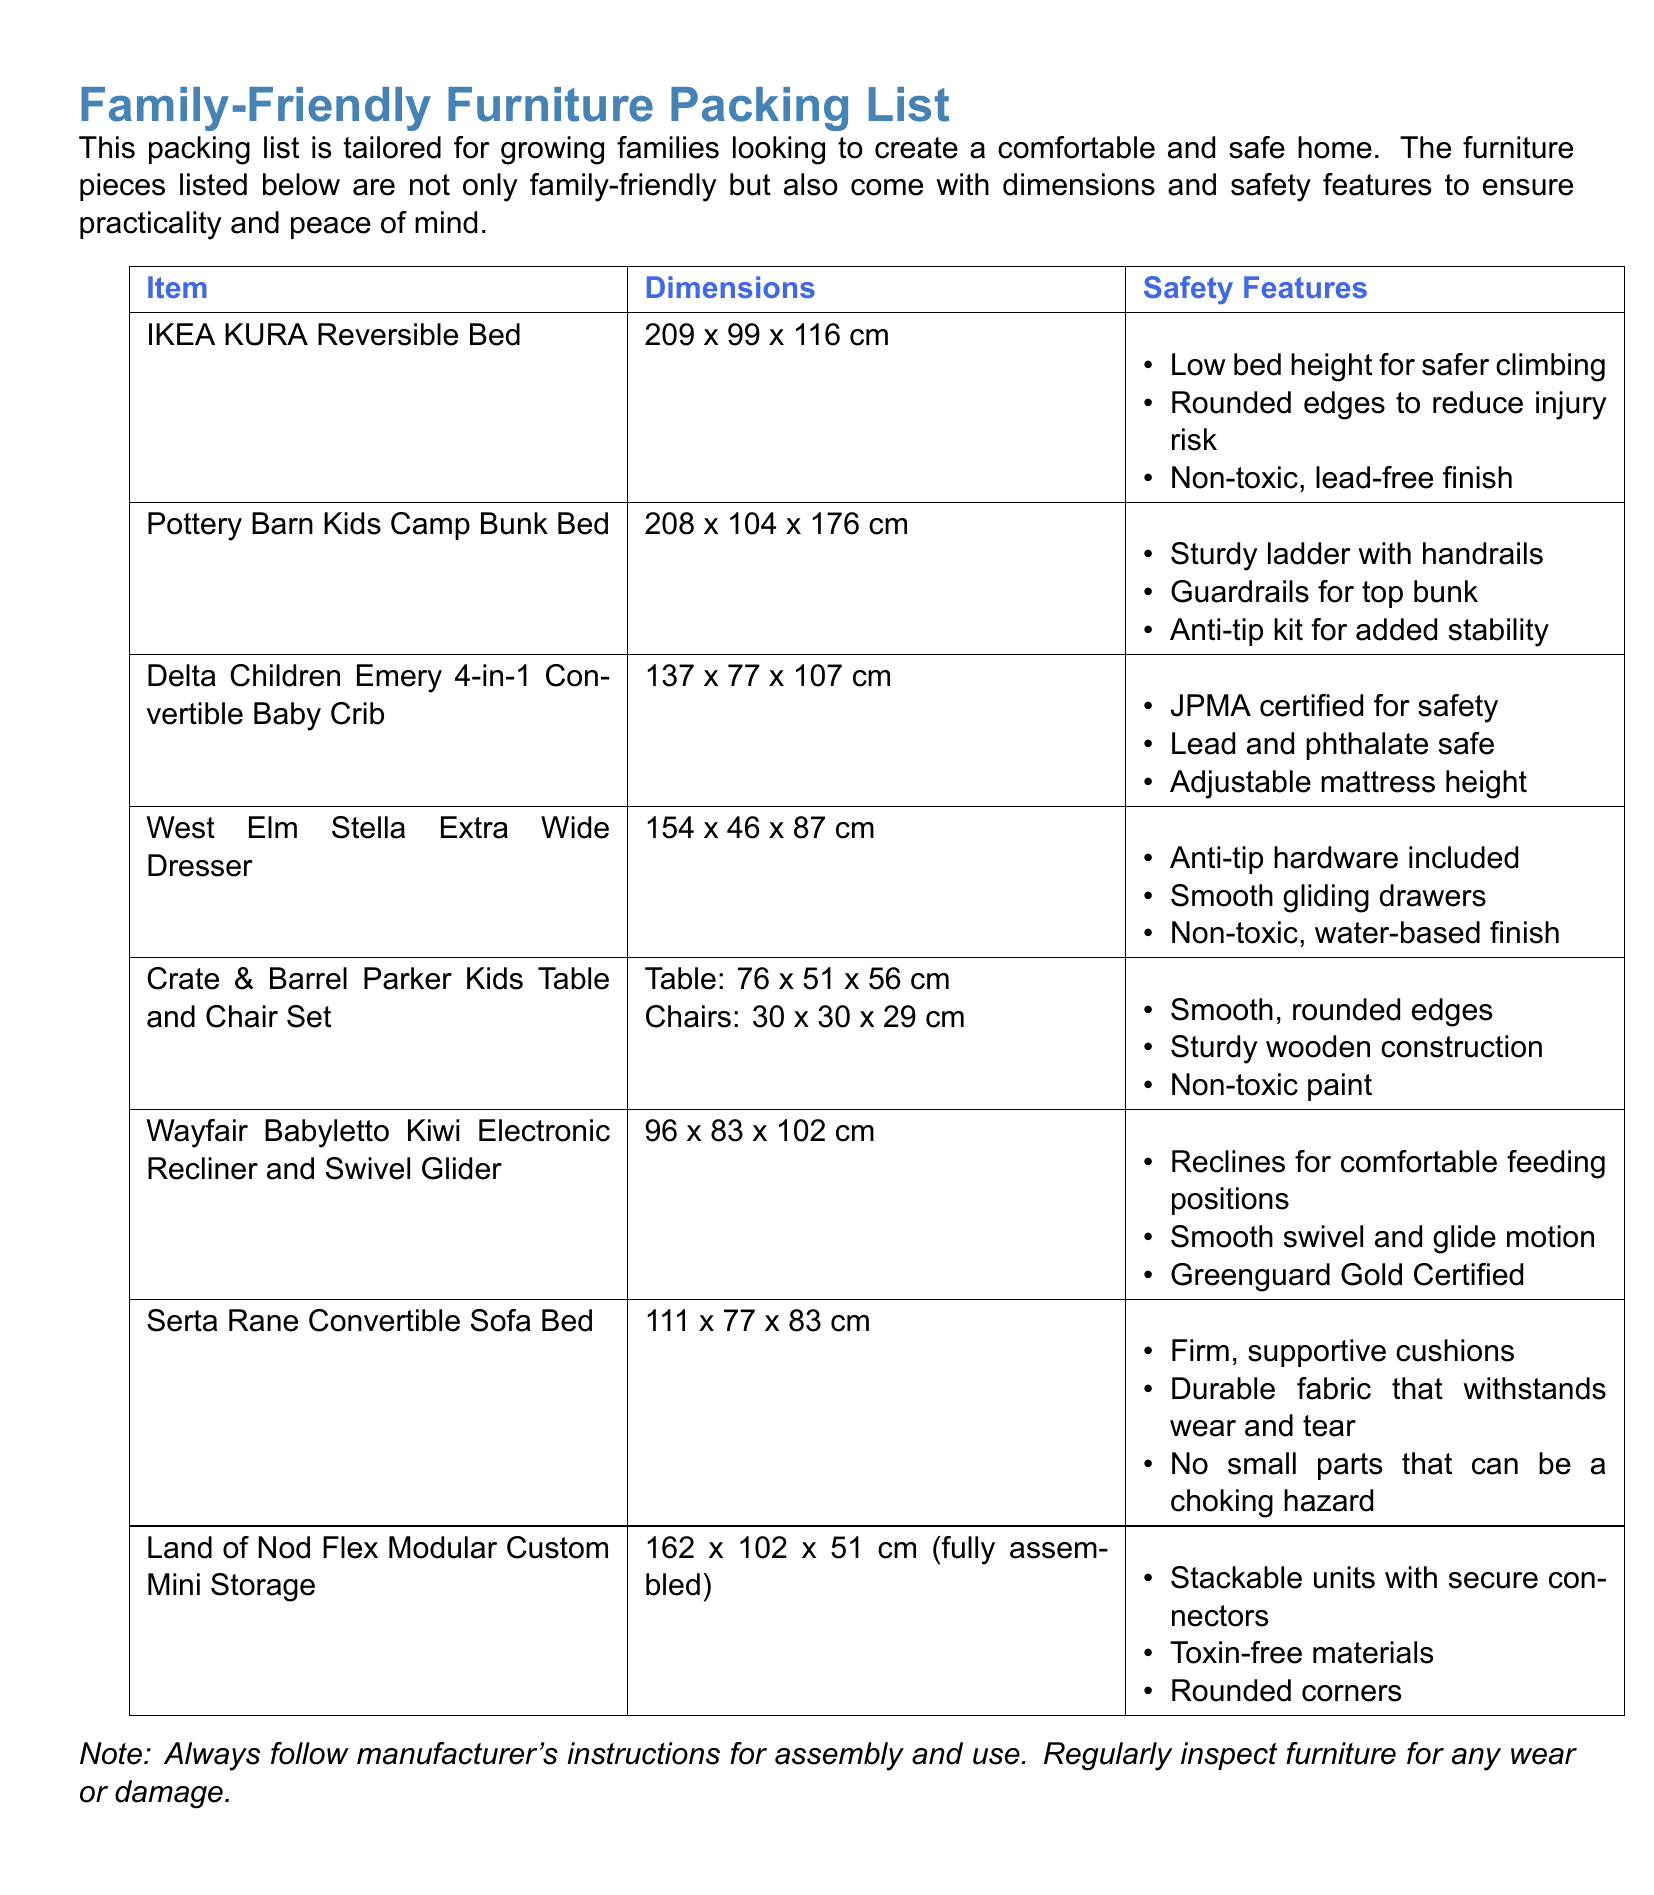What are the dimensions of the IKEA KURA Reversible Bed? The dimensions are provided in the document as 209 x 99 x 116 cm.
Answer: 209 x 99 x 116 cm What safety feature is included with the Delta Children Emery 4-in-1 Convertible Baby Crib? The document lists "JPMA certified for safety" as a safety feature.
Answer: JPMA certified for safety How many safety features are listed for the Crate & Barrel Parker Kids Table and Chair Set? The document provides three safety features for this item.
Answer: Three What is the height of the West Elm Stella Extra Wide Dresser? The height is mentioned in the document as 87 cm.
Answer: 87 cm Which furniture piece comes certified with Greenguard Gold? The document states that the Wayfair Babyletto Kiwi Electronic Recliner and Swivel Glider is Greenguard Gold Certified.
Answer: Wayfair Babyletto Kiwi Electronic Recliner and Swivel Glider What is the width of the Serta Rane Convertible Sofa Bed? The width is provided in the document as 77 cm.
Answer: 77 cm What kind of mattress height adjustment feature does the Delta Children Emery 4-in-1 Convertible Baby Crib offer? The document mentions "Adjustable mattress height" as a feature.
Answer: Adjustable mattress height What is the total number of items listed in the packing list? The document contains a total of eight furniture items listed.
Answer: Eight What material are the Land of Nod Flex Modular Custom Mini Storage units made from? The document specifies "Toxin-free materials" as part of the safety features.
Answer: Toxin-free materials 